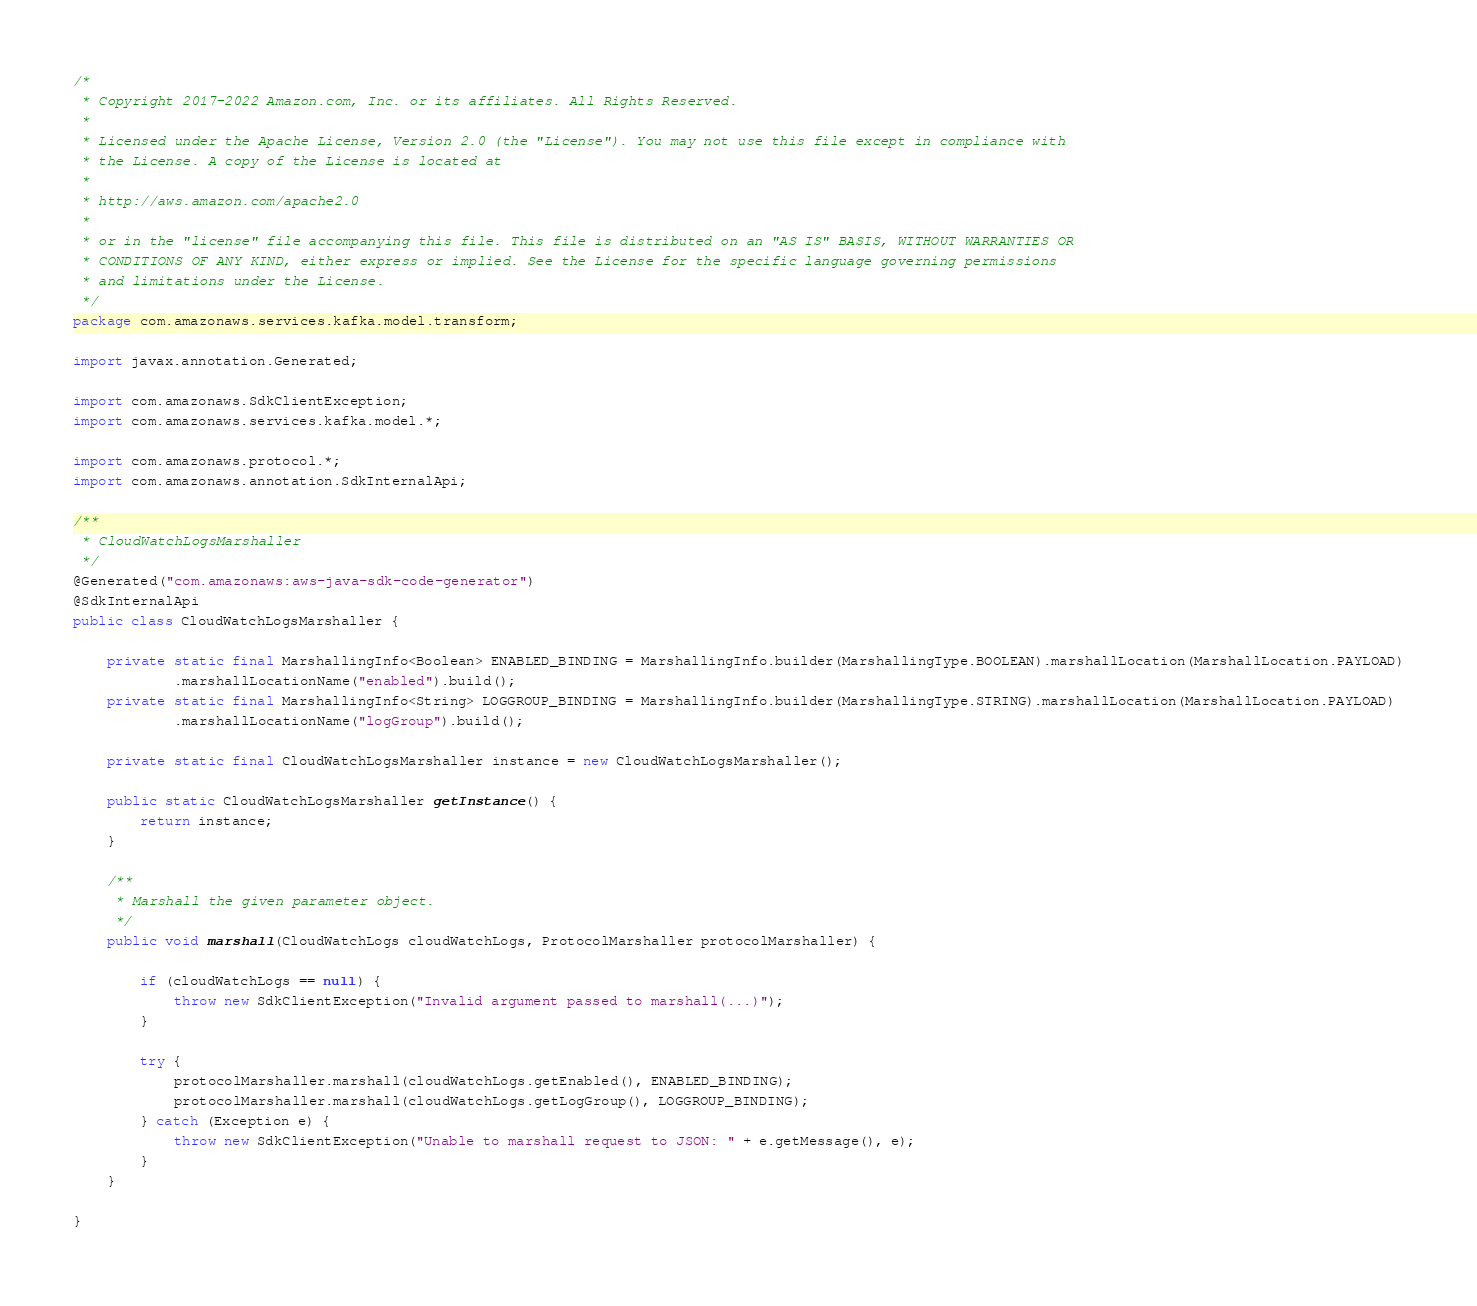<code> <loc_0><loc_0><loc_500><loc_500><_Java_>/*
 * Copyright 2017-2022 Amazon.com, Inc. or its affiliates. All Rights Reserved.
 * 
 * Licensed under the Apache License, Version 2.0 (the "License"). You may not use this file except in compliance with
 * the License. A copy of the License is located at
 * 
 * http://aws.amazon.com/apache2.0
 * 
 * or in the "license" file accompanying this file. This file is distributed on an "AS IS" BASIS, WITHOUT WARRANTIES OR
 * CONDITIONS OF ANY KIND, either express or implied. See the License for the specific language governing permissions
 * and limitations under the License.
 */
package com.amazonaws.services.kafka.model.transform;

import javax.annotation.Generated;

import com.amazonaws.SdkClientException;
import com.amazonaws.services.kafka.model.*;

import com.amazonaws.protocol.*;
import com.amazonaws.annotation.SdkInternalApi;

/**
 * CloudWatchLogsMarshaller
 */
@Generated("com.amazonaws:aws-java-sdk-code-generator")
@SdkInternalApi
public class CloudWatchLogsMarshaller {

    private static final MarshallingInfo<Boolean> ENABLED_BINDING = MarshallingInfo.builder(MarshallingType.BOOLEAN).marshallLocation(MarshallLocation.PAYLOAD)
            .marshallLocationName("enabled").build();
    private static final MarshallingInfo<String> LOGGROUP_BINDING = MarshallingInfo.builder(MarshallingType.STRING).marshallLocation(MarshallLocation.PAYLOAD)
            .marshallLocationName("logGroup").build();

    private static final CloudWatchLogsMarshaller instance = new CloudWatchLogsMarshaller();

    public static CloudWatchLogsMarshaller getInstance() {
        return instance;
    }

    /**
     * Marshall the given parameter object.
     */
    public void marshall(CloudWatchLogs cloudWatchLogs, ProtocolMarshaller protocolMarshaller) {

        if (cloudWatchLogs == null) {
            throw new SdkClientException("Invalid argument passed to marshall(...)");
        }

        try {
            protocolMarshaller.marshall(cloudWatchLogs.getEnabled(), ENABLED_BINDING);
            protocolMarshaller.marshall(cloudWatchLogs.getLogGroup(), LOGGROUP_BINDING);
        } catch (Exception e) {
            throw new SdkClientException("Unable to marshall request to JSON: " + e.getMessage(), e);
        }
    }

}
</code> 